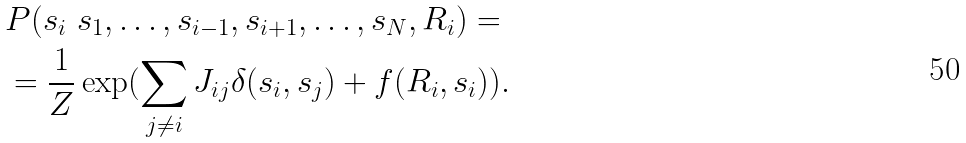<formula> <loc_0><loc_0><loc_500><loc_500>& P ( s _ { i } \ s _ { 1 } , \dots , s _ { i - 1 } , s _ { i + 1 } , \dots , s _ { N } , R _ { i } ) = \\ & = \frac { 1 } { Z } \exp ( \sum _ { j \neq i } J _ { i j } \delta ( s _ { i } , s _ { j } ) + f ( R _ { i } , s _ { i } ) ) .</formula> 